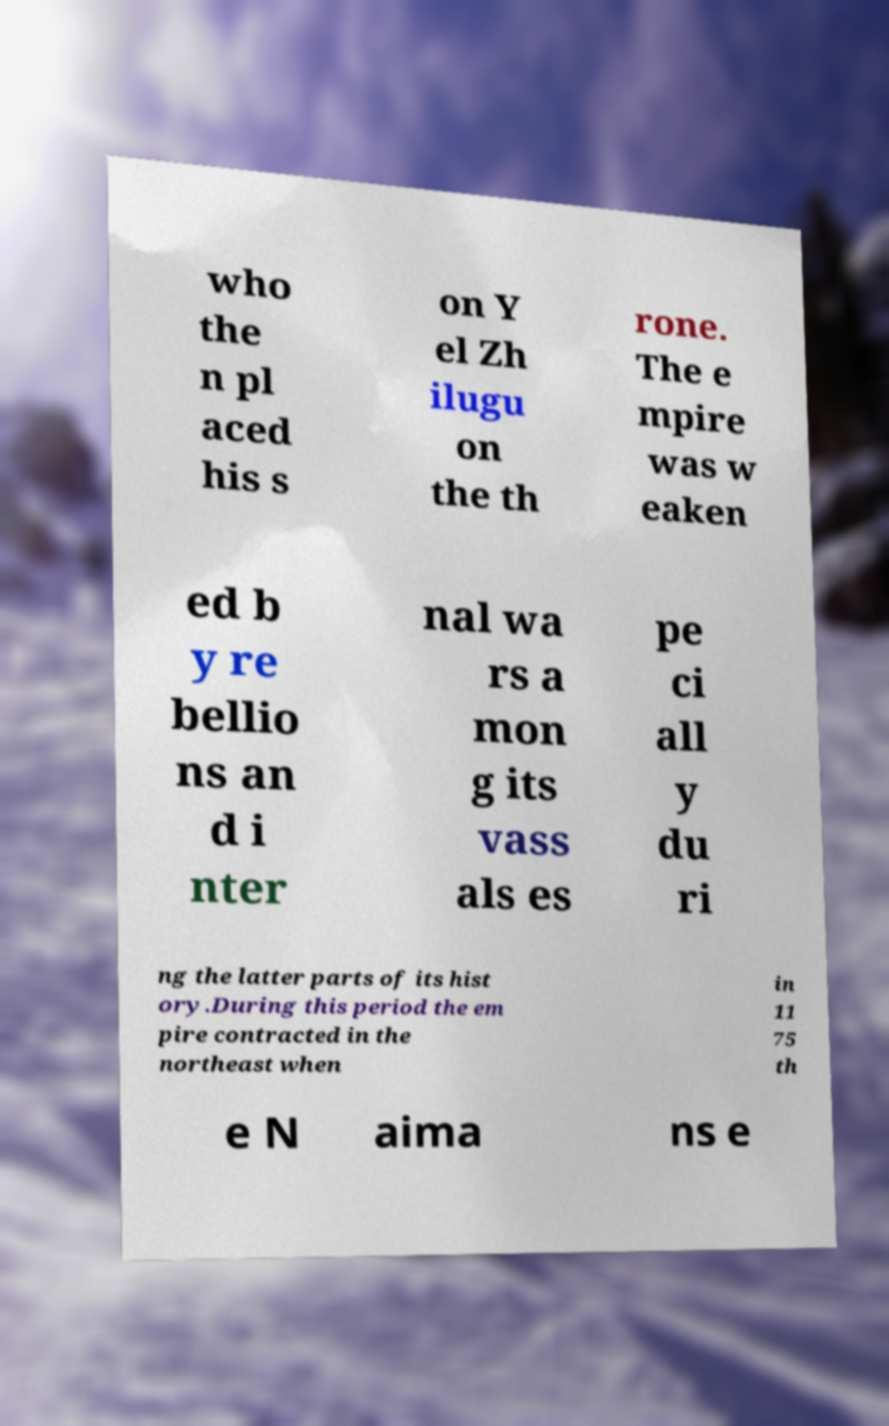There's text embedded in this image that I need extracted. Can you transcribe it verbatim? who the n pl aced his s on Y el Zh ilugu on the th rone. The e mpire was w eaken ed b y re bellio ns an d i nter nal wa rs a mon g its vass als es pe ci all y du ri ng the latter parts of its hist ory.During this period the em pire contracted in the northeast when in 11 75 th e N aima ns e 